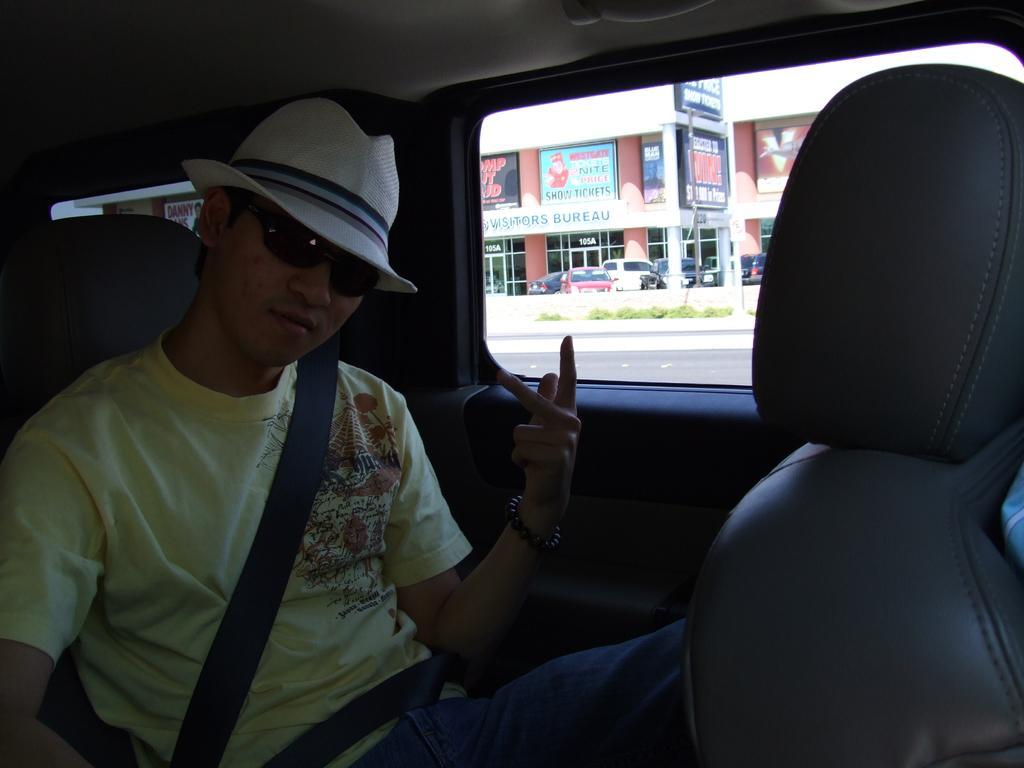How would you summarize this image in a sentence or two? In this picture we can see a man sitting on vehicle with seat belt wore goggles, cap and from window we can see banner, building, door, cars, grass, road. 